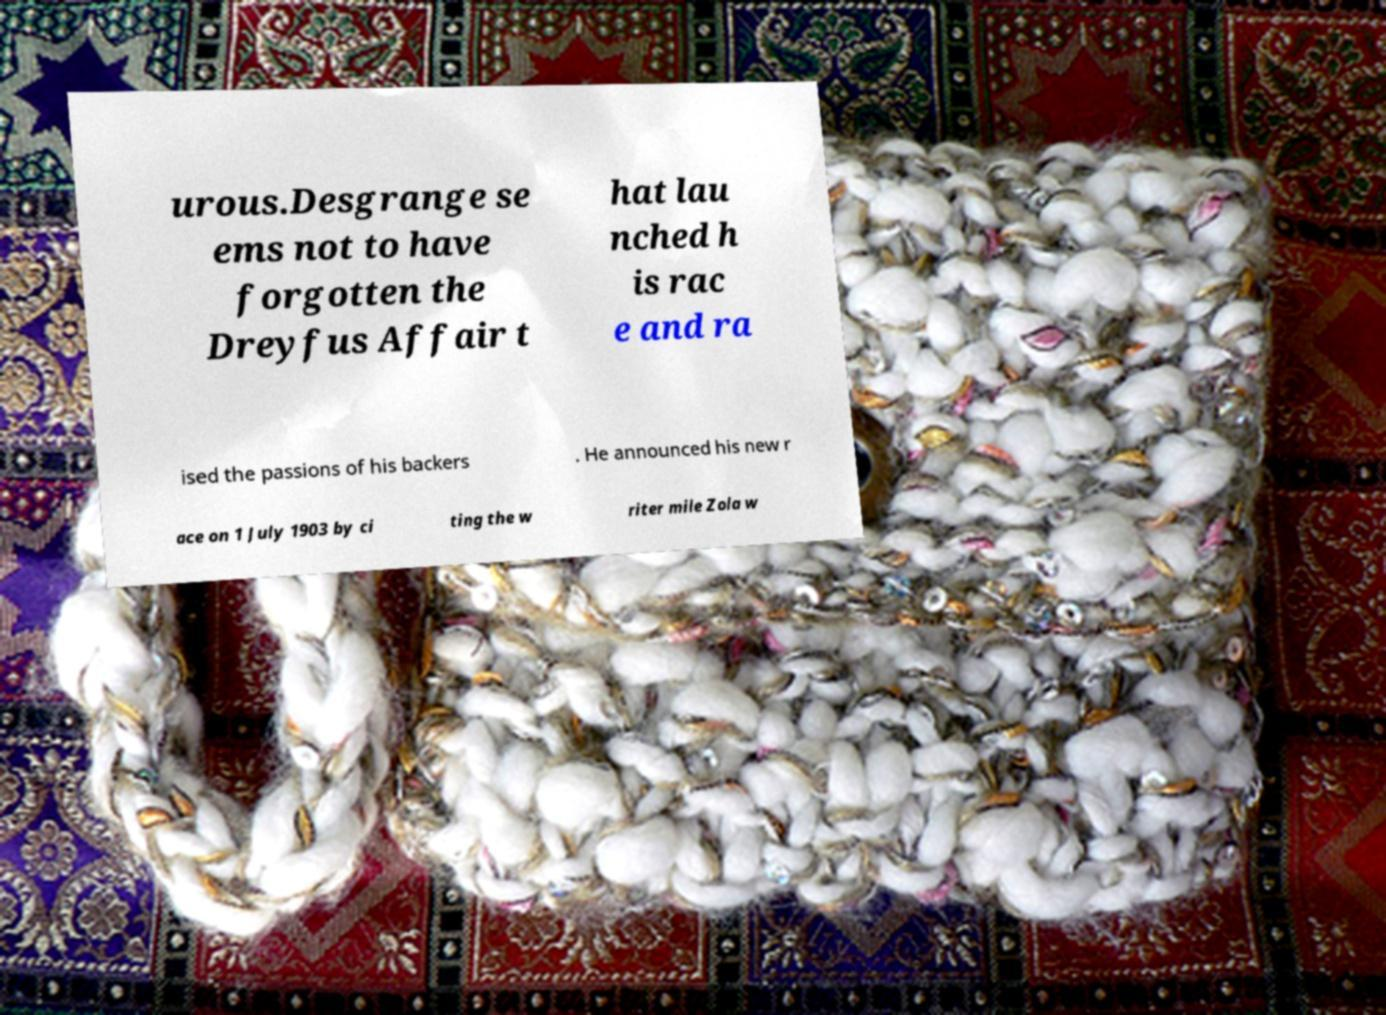For documentation purposes, I need the text within this image transcribed. Could you provide that? urous.Desgrange se ems not to have forgotten the Dreyfus Affair t hat lau nched h is rac e and ra ised the passions of his backers . He announced his new r ace on 1 July 1903 by ci ting the w riter mile Zola w 